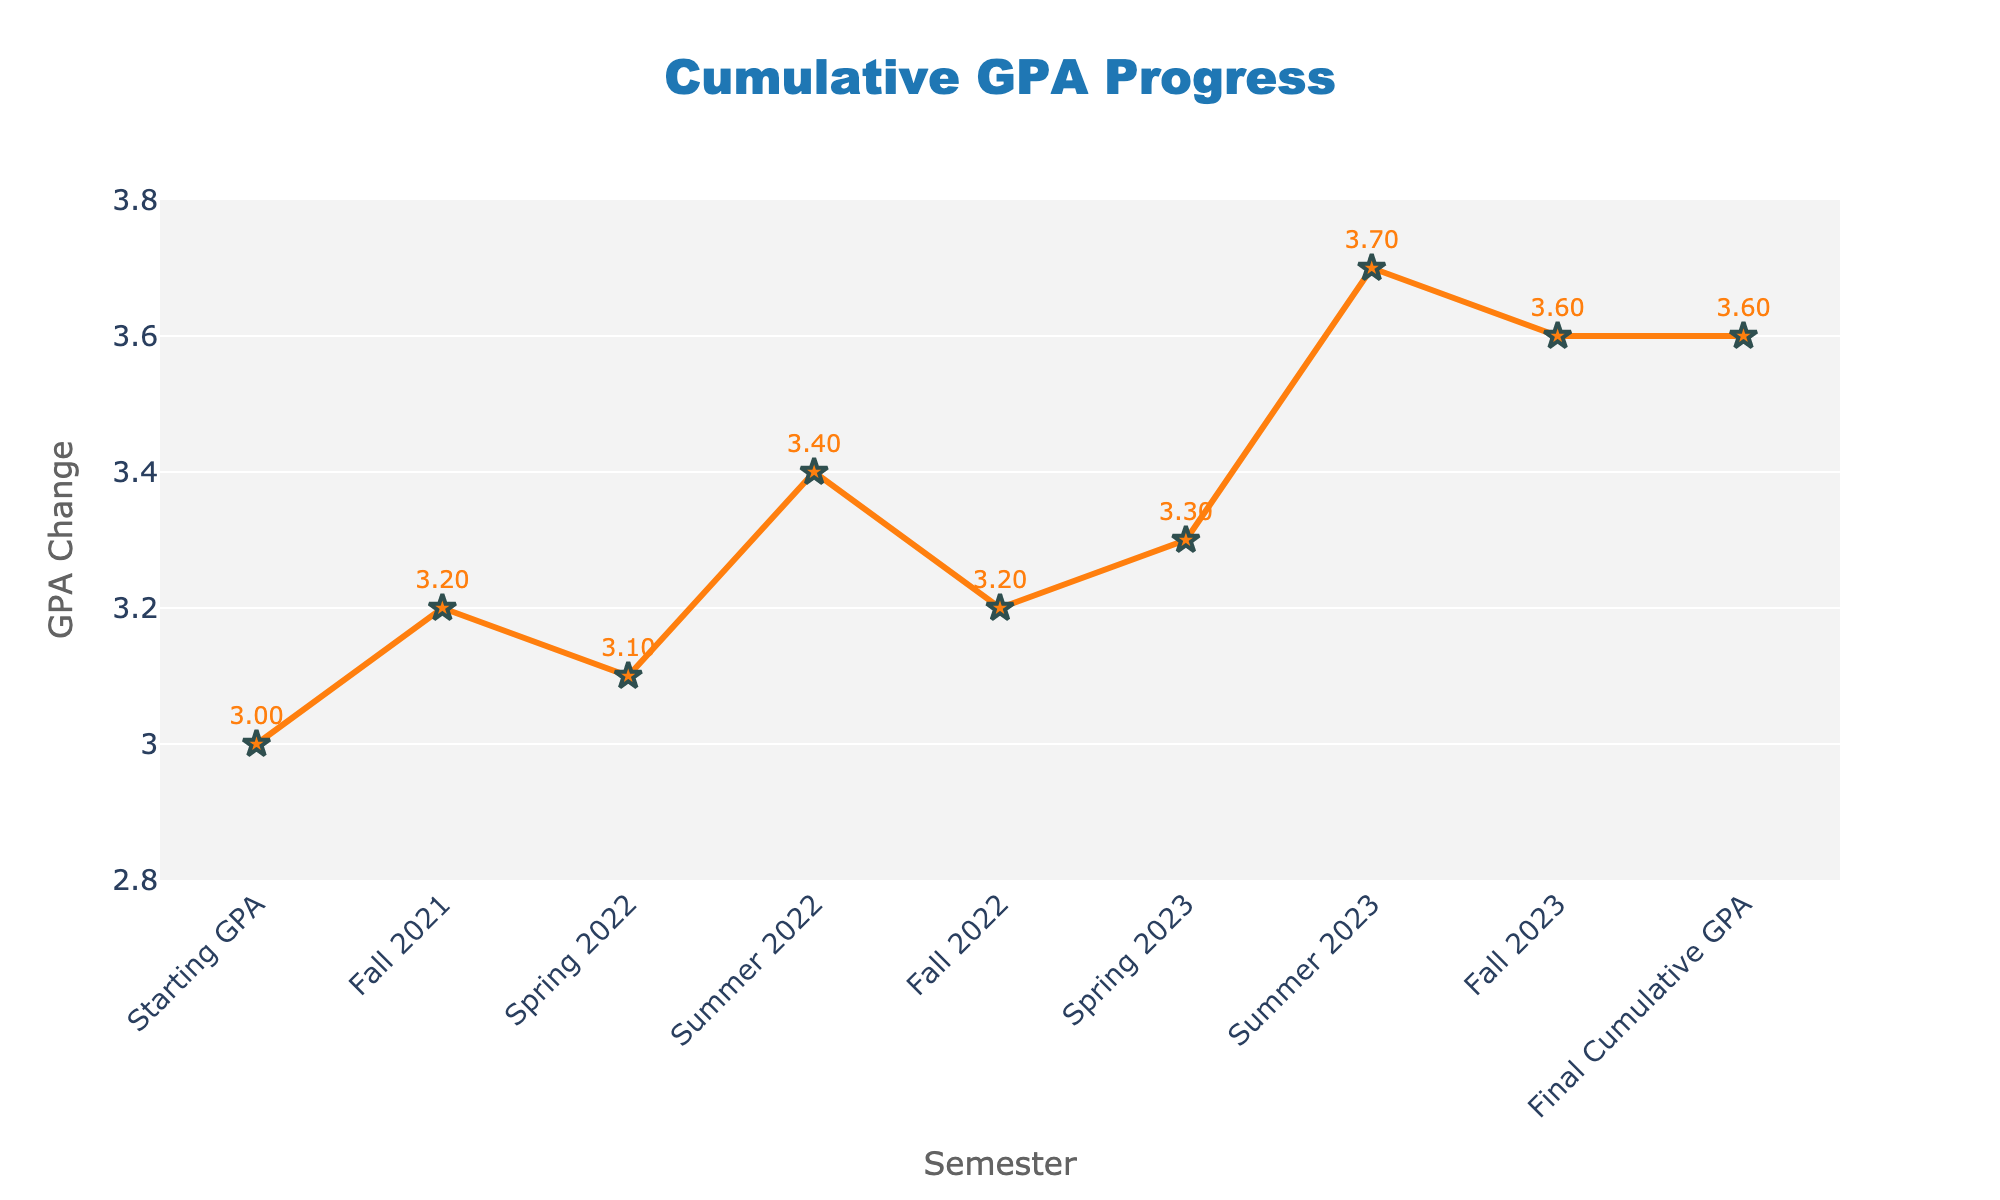What's the title of the chart? The title of the chart is located at the top and reads "Cumulative GPA Progress".
Answer: Cumulative GPA Progress What is the cumulative GPA at the end of Fall 2021? To find the cumulative GPA at the end of Fall 2021, look at the corresponding data point on the line chart labeled "Fall 2021". The value is 3.2.
Answer: 3.2 How does Fall 2022 compare to Summer 2022 in terms of GPA change? In the waterfall chart, Fall 2022 has a GPA change of -0.2, indicated by a red bar, while Summer 2022 has a GPA change of 0.3, indicated by a green bar. Fall 2022 decreases, and Summer 2022 increases.
Answer: Fall 2022 decreases, Summer 2022 increases What is the overall GPA change through Spring 2023? To calculate the overall GPA change through Spring 2023, sum the GPA changes from Fall 2021 to Spring 2023 ((0.2) + (-0.1) + (0.3) + (-0.2) + (0.1)). This results in 0.3.
Answer: 0.3 In which semester did the cumulative GPA reach its lowest point, and what was the value? By examining the line chart, the cumulative GPA is at its lowest at the end of Spring 2022 with a value of 3.1.
Answer: Spring 2022, 3.1 What is the difference in cumulative GPA between Fall 2022 and Spring 2023? The cumulative GPA at the end of Fall 2022 is 3.2 and at the end of Spring 2023 is 3.3. The difference is 3.3 - 3.2 = 0.1.
Answer: 0.1 What impact did Summer 2023 have on the cumulative GPA? Summer 2023 shows an increase in the GPA change by 0.4, as indicated by the green bar on the waterfall chart. This resulted in the cumulative GPA increasing to 3.7.
Answer: Increased 0.4 What is the final cumulative GPA at the end of Fall 2023? The final cumulative GPA is indicated both in the last data point of the line graph and explicitly labeled in the waterfall chart as "Final: 3.6".
Answer: 3.6 Between which two consecutive semesters was the biggest GPA change observed? The biggest GPA change can be observed by comparing the height of the bars. The largest change is in Summer 2023 with a change of 0.4.
Answer: Spring 2023 to Summer 2023 